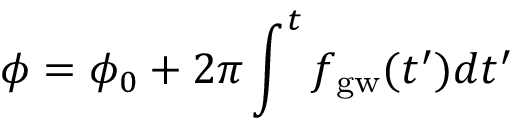<formula> <loc_0><loc_0><loc_500><loc_500>\phi = \phi _ { 0 } + 2 \pi \int ^ { t } f _ { g w } ( t ^ { \prime } ) d t ^ { \prime }</formula> 